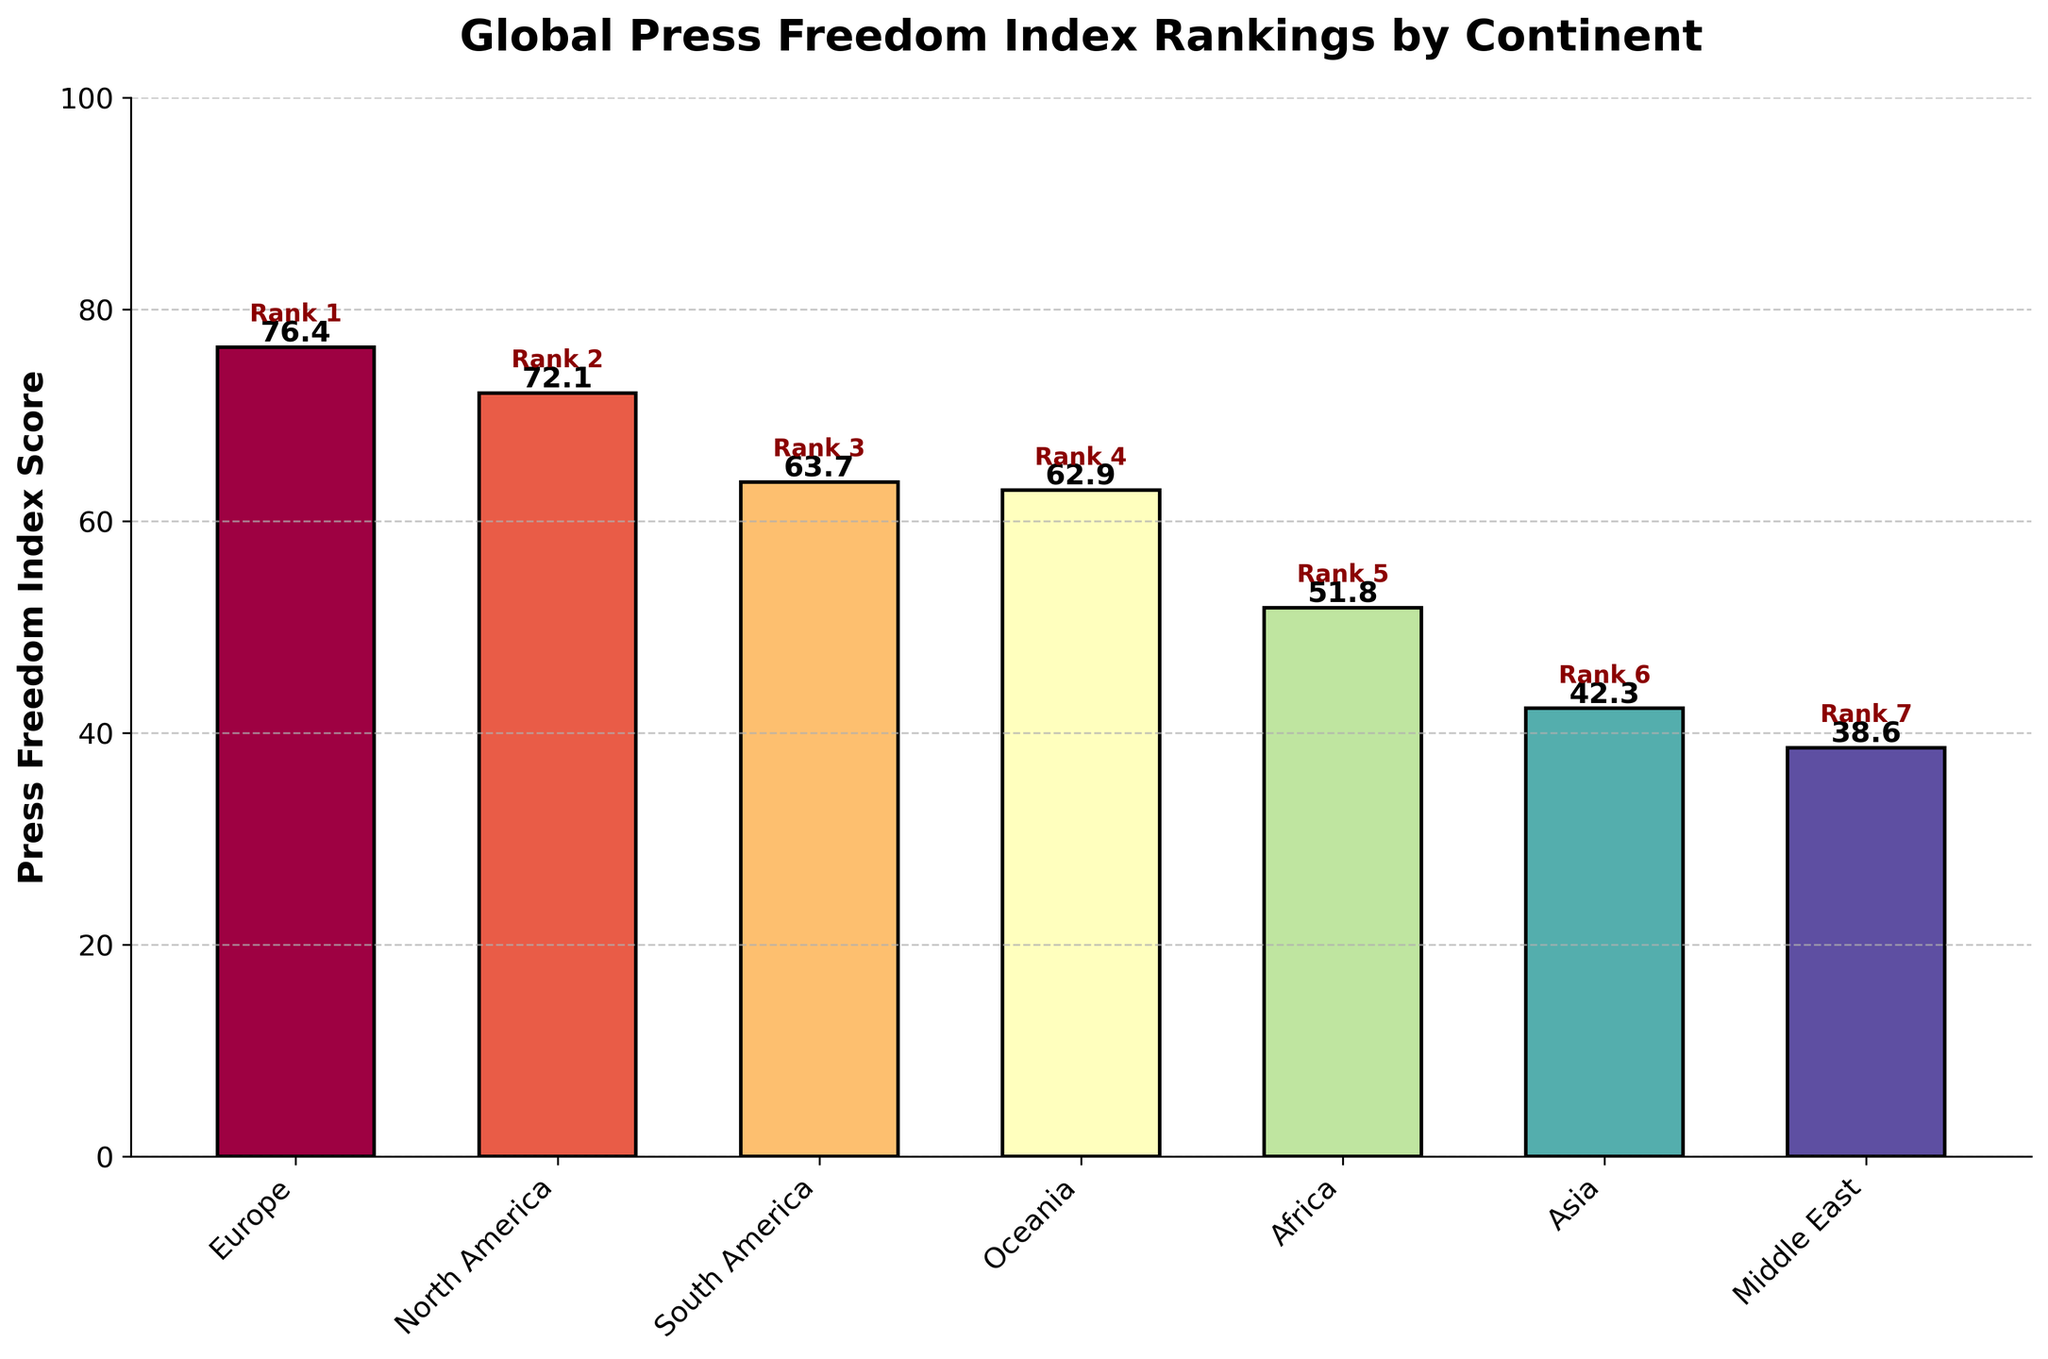What is the highest Press Freedom Index score, and which continent has it? The bar representing Europe is the tallest with a score of 76.4, as indicated by the height and label on the bar.
Answer: Europe, 76.4 Which continent has the lowest Press Freedom Index score? The bar representing the Middle East is the shortest with a score of 38.6.
Answer: Middle East What is the difference in Press Freedom Index scores between Europe and Asia? The Press Freedom Index score for Europe is 76.4 and for Asia is 42.3. The difference is \(76.4 - 42.3 = 34.1\).
Answer: 34.1 Which continents have Press Freedom Index scores above 60? Europe (76.4), North America (72.1), South America (63.7), and Oceania (62.9) all have scores above 60.
Answer: Europe, North America, South America, Oceania Rank the continents from highest to lowest Press Freedom Index score. By examining the height of the bars from tallest to shortest: Europe (76.4), North America (72.1), South America (63.7), Oceania (62.9), Africa (51.8), Asia (42.3), Middle East (38.6).
Answer: Europe, North America, South America, Oceania, Africa, Asia, Middle East What is the average Press Freedom Index score of all continents combined? To find the average: (76.4 + 72.1 + 63.7 + 62.9 + 51.8 + 42.3 + 38.6) / 7 = 407.8 / 7 ≈ 58.26.
Answer: 58.26 How many continents have a Press Freedom Index score lower than Africa? The bars representing Asia (42.3) and the Middle East (38.6) have scores lower than Africa (51.8).
Answer: 2 By how much does North America's Press Freedom Index score exceed that of Africa? The Press Freedom Index score for North America is 72.1, and for Africa it is 51.8. The difference is \(72.1 - 51.8 = 20.3\).
Answer: 20.3 What is the visual color gradient observed among the continents, and which continent does a particular color represent? The colors range from shades of red (for higher scores) to shades of blue and purple (for lower scores). For instance, Europe is colored in a lighter red, representing its high score, and the Middle East is in a dark blue or purple, representing its lower score.
Answer: Red: Europe, Blue/Purple: Middle East 